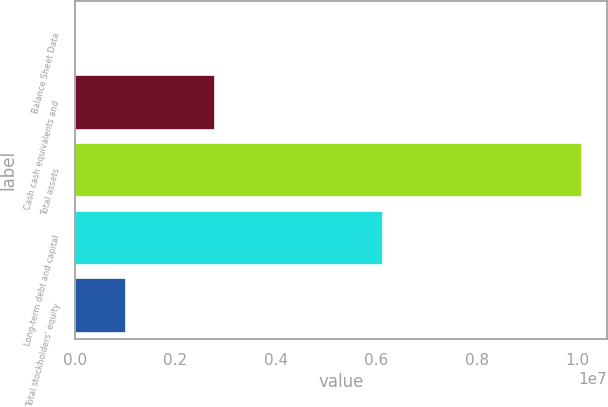Convert chart. <chart><loc_0><loc_0><loc_500><loc_500><bar_chart><fcel>Balance Sheet Data<fcel>Cash cash equivalents and<fcel>Total assets<fcel>Long-term debt and capital<fcel>Total stockholders' equity<nl><fcel>2007<fcel>2.7882e+06<fcel>1.00865e+07<fcel>6.1257e+06<fcel>1.01046e+06<nl></chart> 